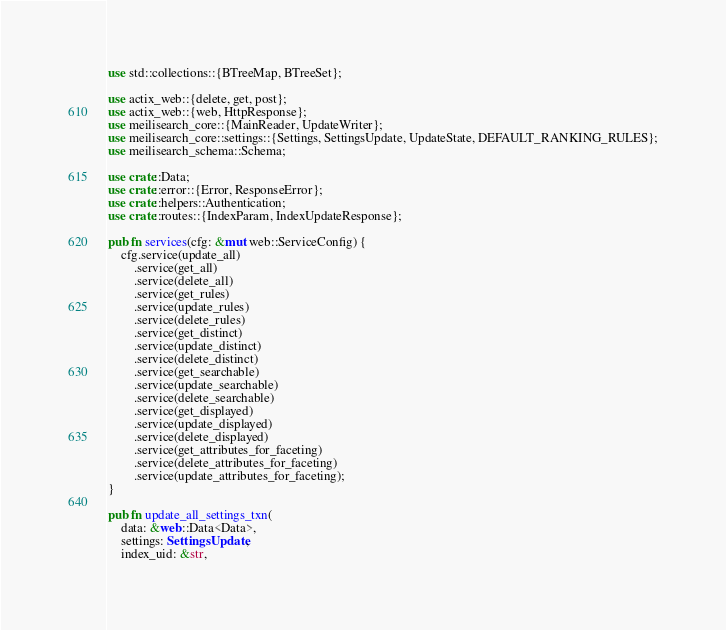<code> <loc_0><loc_0><loc_500><loc_500><_Rust_>use std::collections::{BTreeMap, BTreeSet};

use actix_web::{delete, get, post};
use actix_web::{web, HttpResponse};
use meilisearch_core::{MainReader, UpdateWriter};
use meilisearch_core::settings::{Settings, SettingsUpdate, UpdateState, DEFAULT_RANKING_RULES};
use meilisearch_schema::Schema;

use crate::Data;
use crate::error::{Error, ResponseError};
use crate::helpers::Authentication;
use crate::routes::{IndexParam, IndexUpdateResponse};

pub fn services(cfg: &mut web::ServiceConfig) {
    cfg.service(update_all)
        .service(get_all)
        .service(delete_all)
        .service(get_rules)
        .service(update_rules)
        .service(delete_rules)
        .service(get_distinct)
        .service(update_distinct)
        .service(delete_distinct)
        .service(get_searchable)
        .service(update_searchable)
        .service(delete_searchable)
        .service(get_displayed)
        .service(update_displayed)
        .service(delete_displayed)
        .service(get_attributes_for_faceting)
        .service(delete_attributes_for_faceting)
        .service(update_attributes_for_faceting);
}

pub fn update_all_settings_txn(
    data: &web::Data<Data>,
    settings: SettingsUpdate,
    index_uid: &str,</code> 